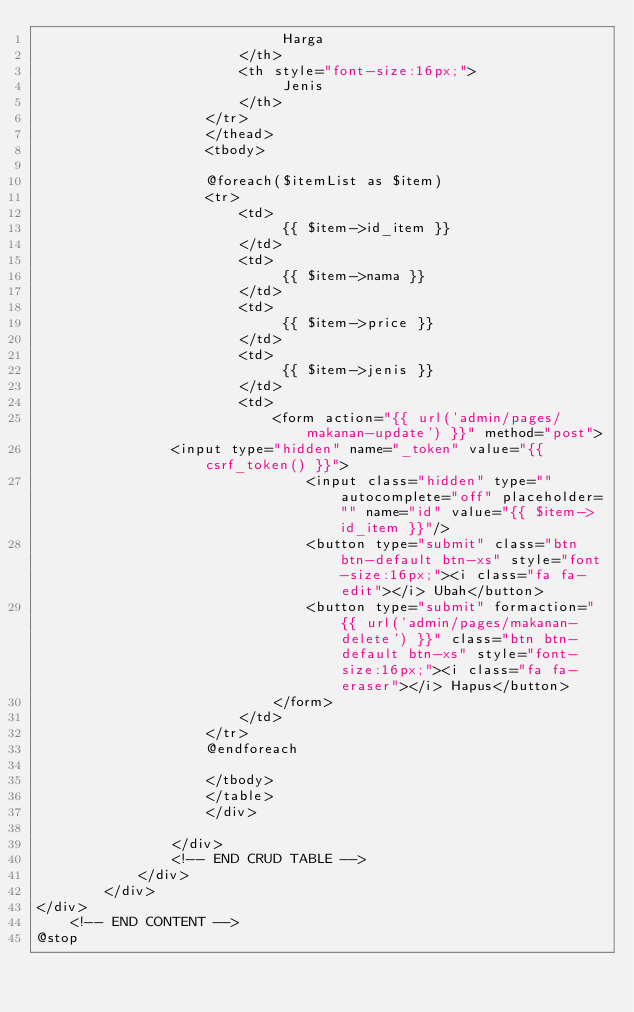<code> <loc_0><loc_0><loc_500><loc_500><_PHP_>                             Harga
                        </th>
                        <th style="font-size:16px;">
                             Jenis
                        </th>
                    </tr>
                    </thead>
                    <tbody>
                    
                    @foreach($itemList as $item)
                    <tr>
                        <td>
                             {{ $item->id_item }}
                        </td>
                        <td>
                             {{ $item->nama }}
                        </td>
                        <td>
                             {{ $item->price }}
                        </td>
                        <td>
                             {{ $item->jenis }}
                        </td>
                        <td>
                            <form action="{{ url('admin/pages/makanan-update') }}" method="post">
                <input type="hidden" name="_token" value="{{ csrf_token() }}">
                                <input class="hidden" type="" autocomplete="off" placeholder="" name="id" value="{{ $item->id_item }}"/>
                                <button type="submit" class="btn btn-default btn-xs" style="font-size:16px;"><i class="fa fa-edit"></i> Ubah</button>
                                <button type="submit" formaction="{{ url('admin/pages/makanan-delete') }}" class="btn btn-default btn-xs" style="font-size:16px;"><i class="fa fa-eraser"></i> Hapus</button>
                            </form>
                        </td>
                    </tr>    
                    @endforeach
                        
                    </tbody>
                    </table>
                    </div>
                    
                </div>
                <!-- END CRUD TABLE -->
            </div>
        </div>
</div>
    <!-- END CONTENT -->
@stop



</code> 